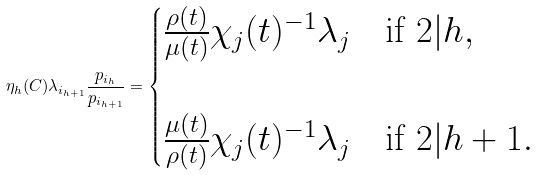Convert formula to latex. <formula><loc_0><loc_0><loc_500><loc_500>\eta _ { h } ( C ) \lambda _ { i _ { h + 1 } } \frac { p _ { i _ { h } } } { p _ { i _ { h + 1 } } } = \begin{cases} \frac { \rho ( t ) } { \mu ( t ) } \chi _ { j } ( t ) ^ { - 1 } \lambda _ { j } & \text {if } 2 | h , \\ \quad & \quad \\ \frac { \mu ( t ) } { \rho ( t ) } \chi _ { j } ( t ) ^ { - 1 } \lambda _ { j } & \text {if } 2 | h + 1 . \end{cases}</formula> 